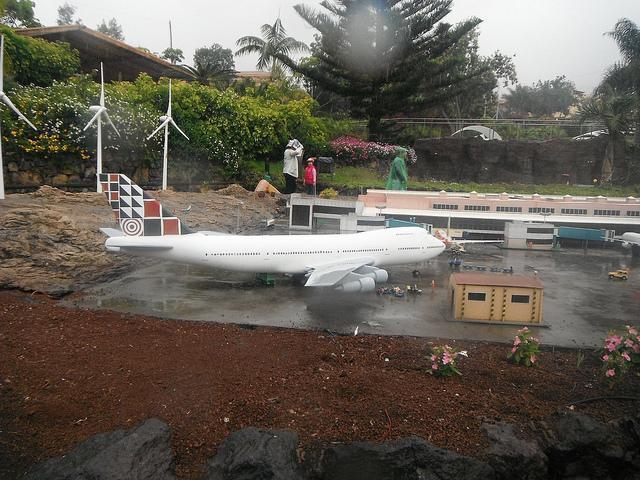What is this place?
Choose the correct response and explain in the format: 'Answer: answer
Rationale: rationale.'
Options: Rodeo, amusement park, airport, daycare. Answer: amusement park.
Rationale: There is an airplane on the ground here. 